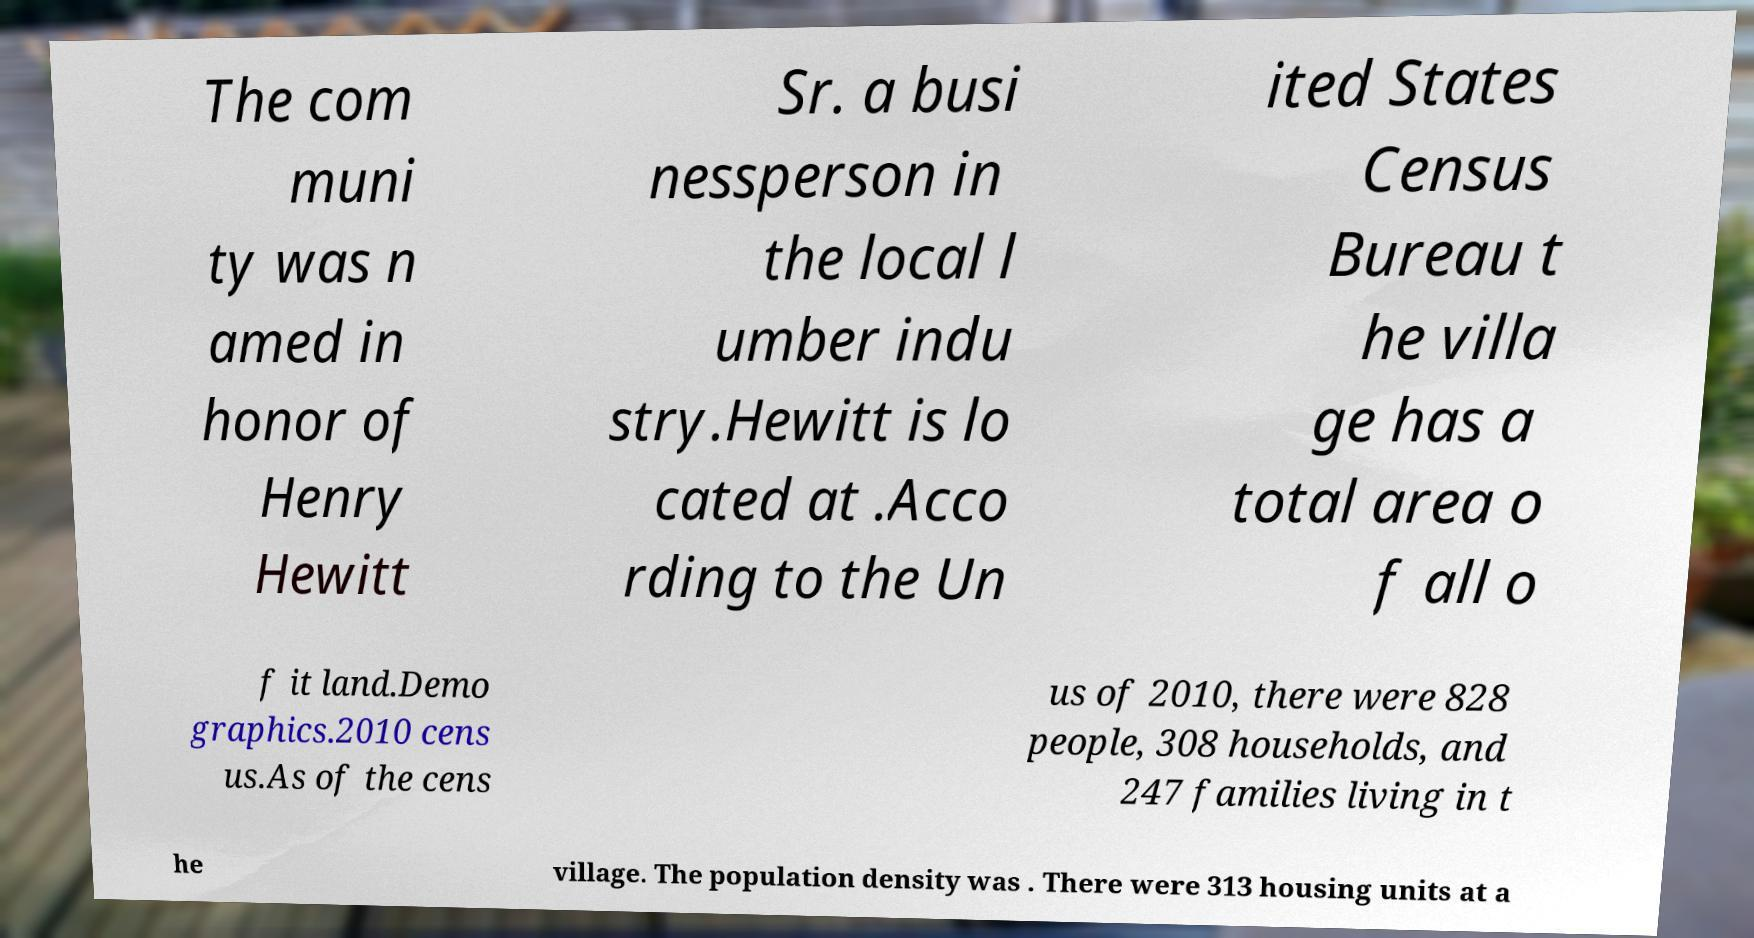Can you accurately transcribe the text from the provided image for me? The com muni ty was n amed in honor of Henry Hewitt Sr. a busi nessperson in the local l umber indu stry.Hewitt is lo cated at .Acco rding to the Un ited States Census Bureau t he villa ge has a total area o f all o f it land.Demo graphics.2010 cens us.As of the cens us of 2010, there were 828 people, 308 households, and 247 families living in t he village. The population density was . There were 313 housing units at a 